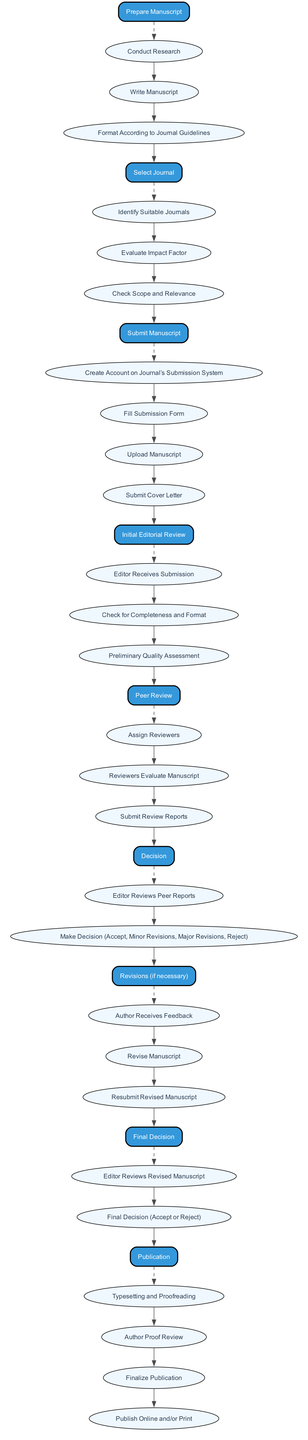What is the first step in the submission workflow? The first step in the workflow is "Prepare Manuscript." This is the initial node in the diagram, indicating it is the starting point for the submission process.
Answer: Prepare Manuscript How many actions are listed under "Submit Manuscript"? There are four actions listed under "Submit Manuscript": "Create Account on Journal’s Submission System," "Fill Submission Form," "Upload Manuscript," and "Submit Cover Letter." Counting these actions gives the total of four.
Answer: 4 What node comes after "Initial Editorial Review"? The node that comes directly after "Initial Editorial Review" in the workflow is "Peer Review." This follows the logical progression of the submission process, where peer review occurs after an initial editorial check.
Answer: Peer Review Which step involves changing the manuscript after receiving feedback? The step that involves changing the manuscript after feedback is named "Revisions (if necessary)." This indicates that authors must revise their work based on the comments provided in the feedback.
Answer: Revisions (if necessary) What is the final step before publication? The final step before publication is "Final Decision." This step occurs after revisions and involves a conclusive review by the editor before proceeding to publication.
Answer: Final Decision Which action is part of the "Publication" step? One of the actions that is part of the "Publication" step is "Publish Online and/or Print." This action indicates the last part where the manuscript is made available to the public.
Answer: Publish Online and/or Print What is the decision that the editor can make after peer review? The editor can make four possible decisions after the peer review: "Accept," "Minor Revisions," "Major Revisions," or "Reject." These options reflect the range of outcomes an editor may choose based on the peer reviews.
Answer: Accept, Minor Revisions, Major Revisions, Reject How does the workflow transition from "Select Journal" to "Submit Manuscript"? The transition from "Select Journal" to "Submit Manuscript" occurs directly, where the end of the actions in "Select Journal" leads to the initiation of the actions involved in "Submit Manuscript." This indicates a sequential flow from choosing a journal to submitting the manuscript.
Answer: Direct Transition Which actions are involved in the "Peer Review" step? The actions involved in the "Peer Review" step are "Assign Reviewers," "Reviewers Evaluate Manuscript," and "Submit Review Reports." These actions outline the peer review process after the initial review by the editor.
Answer: Assign Reviewers, Reviewers Evaluate Manuscript, Submit Review Reports 